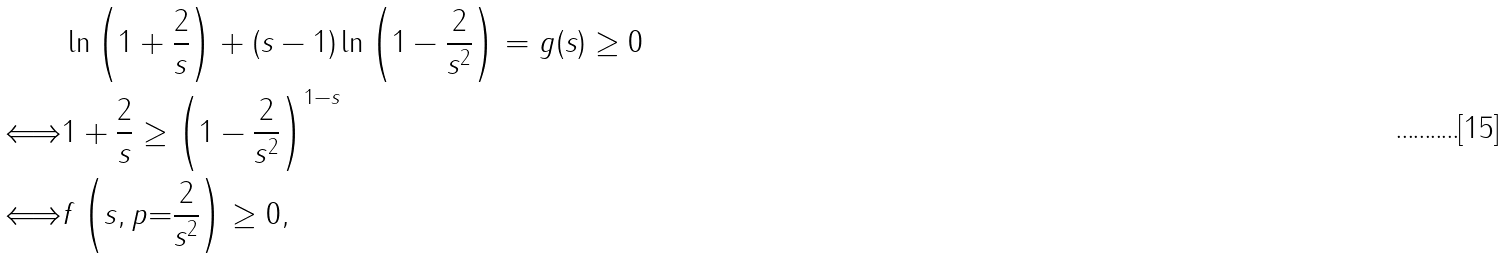<formula> <loc_0><loc_0><loc_500><loc_500>& \ln \left ( 1 + \frac { 2 } { s } \right ) + ( s - 1 ) \ln \left ( 1 - \frac { 2 } { s ^ { 2 } } \right ) = g ( s ) \geq 0 \\ \Longleftrightarrow & 1 + \frac { 2 } { s } \geq \left ( 1 - \frac { 2 } { s ^ { 2 } } \right ) ^ { 1 - s } \\ \Longleftrightarrow & f \left ( s , p { = } \frac { 2 } { s ^ { 2 } } \right ) \geq 0 ,</formula> 